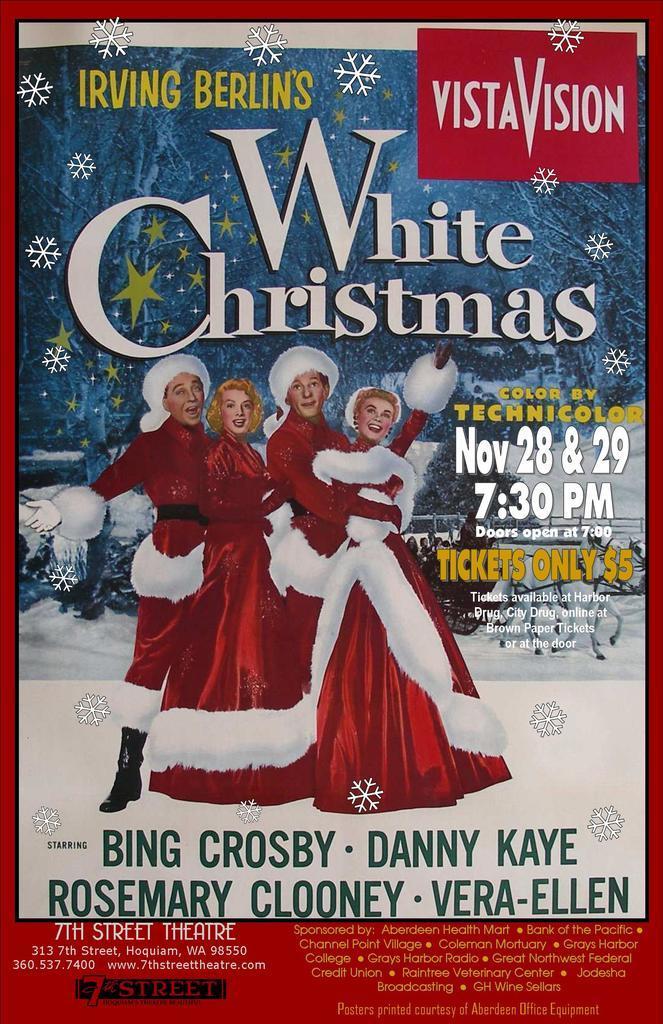In one or two sentences, can you explain what this image depicts? In this image there is a poster in which there are four people who are dressed up in the Christmas costume. 